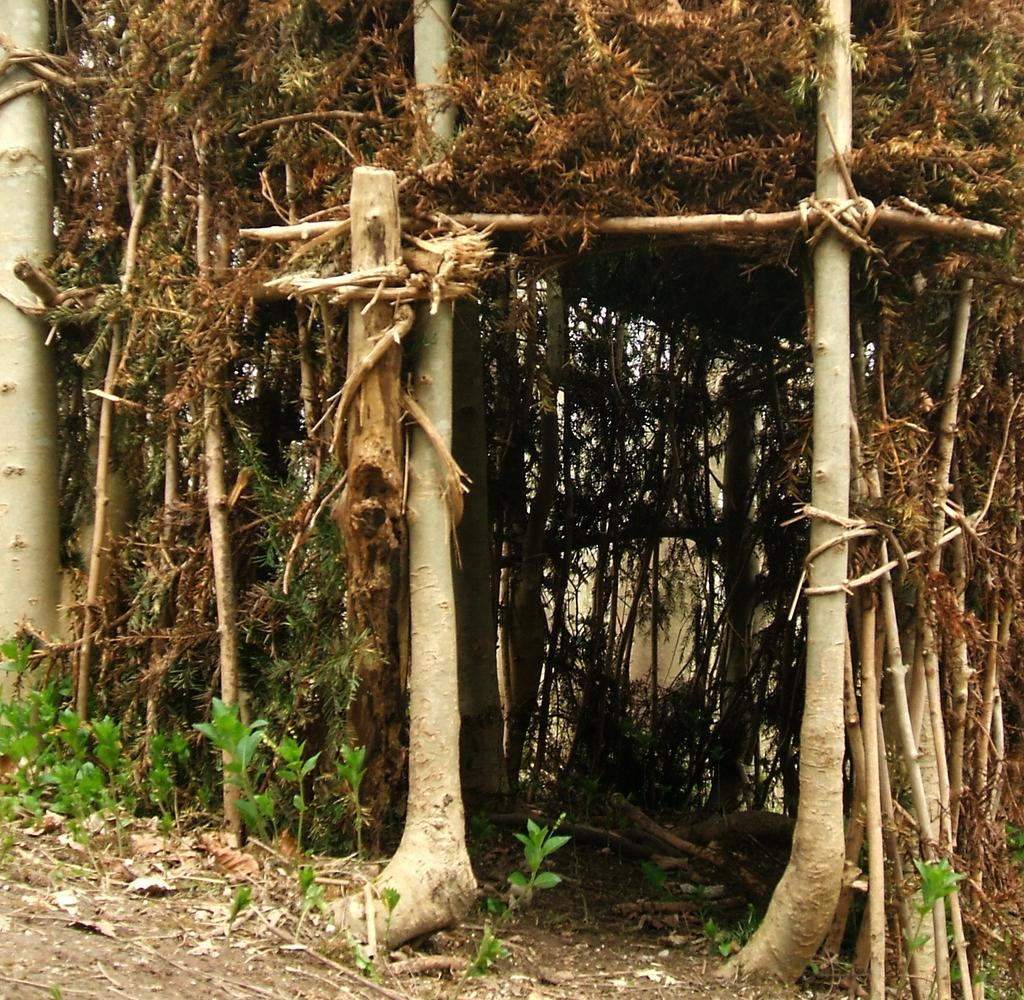What type of structure is present in the image? There is a hut in the picture. What can be seen in front of the hut? There are plants in front of the hut. What type of vessel is being used to rub the plants in the image? There is no vessel or rubbing action involving plants depicted in the image. 